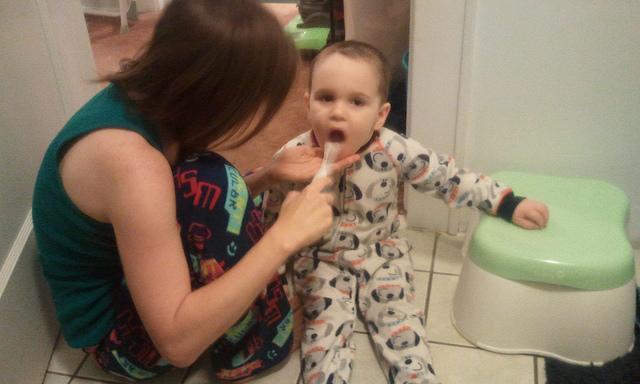What is the woman helping the child do?
Pick the right solution, then justify: 'Answer: answer
Rationale: rationale.'
Options: Cut nails, brush teeth, comb hair, clean ears. Answer: brush teeth.
Rationale: The kid is brushing their teeth. 